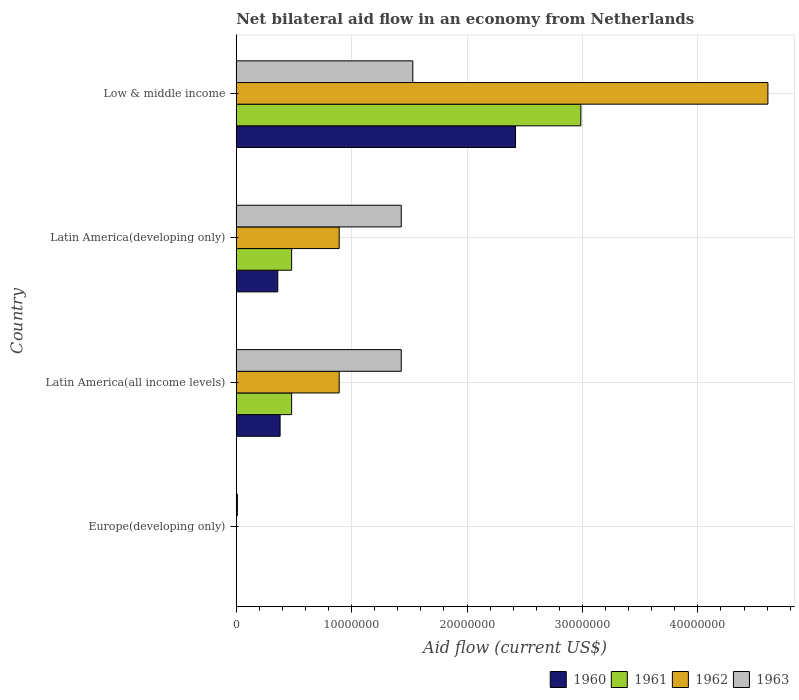How many different coloured bars are there?
Offer a terse response. 4. How many bars are there on the 4th tick from the top?
Ensure brevity in your answer.  1. How many bars are there on the 3rd tick from the bottom?
Offer a terse response. 4. What is the label of the 2nd group of bars from the top?
Provide a short and direct response. Latin America(developing only). What is the net bilateral aid flow in 1962 in Europe(developing only)?
Ensure brevity in your answer.  0. Across all countries, what is the maximum net bilateral aid flow in 1961?
Give a very brief answer. 2.99e+07. Across all countries, what is the minimum net bilateral aid flow in 1960?
Ensure brevity in your answer.  0. What is the total net bilateral aid flow in 1962 in the graph?
Your answer should be compact. 6.39e+07. What is the difference between the net bilateral aid flow in 1963 in Europe(developing only) and that in Latin America(developing only)?
Provide a succinct answer. -1.42e+07. What is the difference between the net bilateral aid flow in 1963 in Latin America(developing only) and the net bilateral aid flow in 1960 in Low & middle income?
Ensure brevity in your answer.  -9.90e+06. What is the average net bilateral aid flow in 1963 per country?
Your response must be concise. 1.10e+07. What is the difference between the net bilateral aid flow in 1962 and net bilateral aid flow in 1963 in Latin America(developing only)?
Your response must be concise. -5.38e+06. What is the ratio of the net bilateral aid flow in 1962 in Latin America(developing only) to that in Low & middle income?
Your response must be concise. 0.19. Is the difference between the net bilateral aid flow in 1962 in Latin America(developing only) and Low & middle income greater than the difference between the net bilateral aid flow in 1963 in Latin America(developing only) and Low & middle income?
Provide a short and direct response. No. What is the difference between the highest and the second highest net bilateral aid flow in 1962?
Your answer should be very brief. 3.72e+07. What is the difference between the highest and the lowest net bilateral aid flow in 1961?
Offer a terse response. 2.99e+07. Is it the case that in every country, the sum of the net bilateral aid flow in 1962 and net bilateral aid flow in 1963 is greater than the net bilateral aid flow in 1960?
Provide a succinct answer. Yes. What is the difference between two consecutive major ticks on the X-axis?
Your answer should be compact. 1.00e+07. Are the values on the major ticks of X-axis written in scientific E-notation?
Offer a very short reply. No. Does the graph contain any zero values?
Make the answer very short. Yes. Does the graph contain grids?
Provide a short and direct response. Yes. How are the legend labels stacked?
Make the answer very short. Horizontal. What is the title of the graph?
Keep it short and to the point. Net bilateral aid flow in an economy from Netherlands. Does "1990" appear as one of the legend labels in the graph?
Provide a short and direct response. No. What is the Aid flow (current US$) in 1960 in Europe(developing only)?
Provide a succinct answer. 0. What is the Aid flow (current US$) in 1962 in Europe(developing only)?
Make the answer very short. 0. What is the Aid flow (current US$) in 1963 in Europe(developing only)?
Offer a very short reply. 1.00e+05. What is the Aid flow (current US$) in 1960 in Latin America(all income levels)?
Offer a terse response. 3.80e+06. What is the Aid flow (current US$) of 1961 in Latin America(all income levels)?
Offer a very short reply. 4.80e+06. What is the Aid flow (current US$) of 1962 in Latin America(all income levels)?
Offer a very short reply. 8.92e+06. What is the Aid flow (current US$) of 1963 in Latin America(all income levels)?
Provide a succinct answer. 1.43e+07. What is the Aid flow (current US$) in 1960 in Latin America(developing only)?
Provide a short and direct response. 3.60e+06. What is the Aid flow (current US$) in 1961 in Latin America(developing only)?
Offer a very short reply. 4.80e+06. What is the Aid flow (current US$) in 1962 in Latin America(developing only)?
Ensure brevity in your answer.  8.92e+06. What is the Aid flow (current US$) of 1963 in Latin America(developing only)?
Your answer should be very brief. 1.43e+07. What is the Aid flow (current US$) of 1960 in Low & middle income?
Provide a short and direct response. 2.42e+07. What is the Aid flow (current US$) of 1961 in Low & middle income?
Your answer should be very brief. 2.99e+07. What is the Aid flow (current US$) of 1962 in Low & middle income?
Keep it short and to the point. 4.61e+07. What is the Aid flow (current US$) of 1963 in Low & middle income?
Provide a succinct answer. 1.53e+07. Across all countries, what is the maximum Aid flow (current US$) of 1960?
Offer a terse response. 2.42e+07. Across all countries, what is the maximum Aid flow (current US$) in 1961?
Ensure brevity in your answer.  2.99e+07. Across all countries, what is the maximum Aid flow (current US$) in 1962?
Provide a short and direct response. 4.61e+07. Across all countries, what is the maximum Aid flow (current US$) of 1963?
Give a very brief answer. 1.53e+07. Across all countries, what is the minimum Aid flow (current US$) in 1960?
Give a very brief answer. 0. What is the total Aid flow (current US$) of 1960 in the graph?
Your answer should be very brief. 3.16e+07. What is the total Aid flow (current US$) of 1961 in the graph?
Provide a short and direct response. 3.95e+07. What is the total Aid flow (current US$) in 1962 in the graph?
Your answer should be very brief. 6.39e+07. What is the total Aid flow (current US$) of 1963 in the graph?
Make the answer very short. 4.40e+07. What is the difference between the Aid flow (current US$) in 1963 in Europe(developing only) and that in Latin America(all income levels)?
Keep it short and to the point. -1.42e+07. What is the difference between the Aid flow (current US$) of 1963 in Europe(developing only) and that in Latin America(developing only)?
Offer a very short reply. -1.42e+07. What is the difference between the Aid flow (current US$) of 1963 in Europe(developing only) and that in Low & middle income?
Ensure brevity in your answer.  -1.52e+07. What is the difference between the Aid flow (current US$) of 1963 in Latin America(all income levels) and that in Latin America(developing only)?
Make the answer very short. 0. What is the difference between the Aid flow (current US$) of 1960 in Latin America(all income levels) and that in Low & middle income?
Offer a very short reply. -2.04e+07. What is the difference between the Aid flow (current US$) in 1961 in Latin America(all income levels) and that in Low & middle income?
Ensure brevity in your answer.  -2.51e+07. What is the difference between the Aid flow (current US$) of 1962 in Latin America(all income levels) and that in Low & middle income?
Ensure brevity in your answer.  -3.72e+07. What is the difference between the Aid flow (current US$) of 1960 in Latin America(developing only) and that in Low & middle income?
Keep it short and to the point. -2.06e+07. What is the difference between the Aid flow (current US$) of 1961 in Latin America(developing only) and that in Low & middle income?
Give a very brief answer. -2.51e+07. What is the difference between the Aid flow (current US$) of 1962 in Latin America(developing only) and that in Low & middle income?
Provide a succinct answer. -3.72e+07. What is the difference between the Aid flow (current US$) of 1960 in Latin America(all income levels) and the Aid flow (current US$) of 1962 in Latin America(developing only)?
Offer a terse response. -5.12e+06. What is the difference between the Aid flow (current US$) of 1960 in Latin America(all income levels) and the Aid flow (current US$) of 1963 in Latin America(developing only)?
Your answer should be compact. -1.05e+07. What is the difference between the Aid flow (current US$) in 1961 in Latin America(all income levels) and the Aid flow (current US$) in 1962 in Latin America(developing only)?
Offer a terse response. -4.12e+06. What is the difference between the Aid flow (current US$) in 1961 in Latin America(all income levels) and the Aid flow (current US$) in 1963 in Latin America(developing only)?
Keep it short and to the point. -9.50e+06. What is the difference between the Aid flow (current US$) in 1962 in Latin America(all income levels) and the Aid flow (current US$) in 1963 in Latin America(developing only)?
Provide a succinct answer. -5.38e+06. What is the difference between the Aid flow (current US$) of 1960 in Latin America(all income levels) and the Aid flow (current US$) of 1961 in Low & middle income?
Your answer should be compact. -2.61e+07. What is the difference between the Aid flow (current US$) of 1960 in Latin America(all income levels) and the Aid flow (current US$) of 1962 in Low & middle income?
Your response must be concise. -4.23e+07. What is the difference between the Aid flow (current US$) in 1960 in Latin America(all income levels) and the Aid flow (current US$) in 1963 in Low & middle income?
Your response must be concise. -1.15e+07. What is the difference between the Aid flow (current US$) of 1961 in Latin America(all income levels) and the Aid flow (current US$) of 1962 in Low & middle income?
Your response must be concise. -4.13e+07. What is the difference between the Aid flow (current US$) in 1961 in Latin America(all income levels) and the Aid flow (current US$) in 1963 in Low & middle income?
Your response must be concise. -1.05e+07. What is the difference between the Aid flow (current US$) in 1962 in Latin America(all income levels) and the Aid flow (current US$) in 1963 in Low & middle income?
Offer a terse response. -6.38e+06. What is the difference between the Aid flow (current US$) of 1960 in Latin America(developing only) and the Aid flow (current US$) of 1961 in Low & middle income?
Offer a very short reply. -2.63e+07. What is the difference between the Aid flow (current US$) in 1960 in Latin America(developing only) and the Aid flow (current US$) in 1962 in Low & middle income?
Provide a short and direct response. -4.25e+07. What is the difference between the Aid flow (current US$) in 1960 in Latin America(developing only) and the Aid flow (current US$) in 1963 in Low & middle income?
Your answer should be compact. -1.17e+07. What is the difference between the Aid flow (current US$) in 1961 in Latin America(developing only) and the Aid flow (current US$) in 1962 in Low & middle income?
Your answer should be compact. -4.13e+07. What is the difference between the Aid flow (current US$) in 1961 in Latin America(developing only) and the Aid flow (current US$) in 1963 in Low & middle income?
Offer a terse response. -1.05e+07. What is the difference between the Aid flow (current US$) in 1962 in Latin America(developing only) and the Aid flow (current US$) in 1963 in Low & middle income?
Offer a very short reply. -6.38e+06. What is the average Aid flow (current US$) in 1960 per country?
Your answer should be compact. 7.90e+06. What is the average Aid flow (current US$) of 1961 per country?
Provide a succinct answer. 9.86e+06. What is the average Aid flow (current US$) in 1962 per country?
Your response must be concise. 1.60e+07. What is the average Aid flow (current US$) of 1963 per country?
Ensure brevity in your answer.  1.10e+07. What is the difference between the Aid flow (current US$) in 1960 and Aid flow (current US$) in 1961 in Latin America(all income levels)?
Ensure brevity in your answer.  -1.00e+06. What is the difference between the Aid flow (current US$) in 1960 and Aid flow (current US$) in 1962 in Latin America(all income levels)?
Make the answer very short. -5.12e+06. What is the difference between the Aid flow (current US$) of 1960 and Aid flow (current US$) of 1963 in Latin America(all income levels)?
Give a very brief answer. -1.05e+07. What is the difference between the Aid flow (current US$) in 1961 and Aid flow (current US$) in 1962 in Latin America(all income levels)?
Your answer should be compact. -4.12e+06. What is the difference between the Aid flow (current US$) of 1961 and Aid flow (current US$) of 1963 in Latin America(all income levels)?
Give a very brief answer. -9.50e+06. What is the difference between the Aid flow (current US$) in 1962 and Aid flow (current US$) in 1963 in Latin America(all income levels)?
Ensure brevity in your answer.  -5.38e+06. What is the difference between the Aid flow (current US$) of 1960 and Aid flow (current US$) of 1961 in Latin America(developing only)?
Ensure brevity in your answer.  -1.20e+06. What is the difference between the Aid flow (current US$) in 1960 and Aid flow (current US$) in 1962 in Latin America(developing only)?
Offer a terse response. -5.32e+06. What is the difference between the Aid flow (current US$) in 1960 and Aid flow (current US$) in 1963 in Latin America(developing only)?
Provide a short and direct response. -1.07e+07. What is the difference between the Aid flow (current US$) of 1961 and Aid flow (current US$) of 1962 in Latin America(developing only)?
Offer a terse response. -4.12e+06. What is the difference between the Aid flow (current US$) of 1961 and Aid flow (current US$) of 1963 in Latin America(developing only)?
Ensure brevity in your answer.  -9.50e+06. What is the difference between the Aid flow (current US$) of 1962 and Aid flow (current US$) of 1963 in Latin America(developing only)?
Your answer should be compact. -5.38e+06. What is the difference between the Aid flow (current US$) of 1960 and Aid flow (current US$) of 1961 in Low & middle income?
Your answer should be compact. -5.66e+06. What is the difference between the Aid flow (current US$) in 1960 and Aid flow (current US$) in 1962 in Low & middle income?
Your answer should be very brief. -2.19e+07. What is the difference between the Aid flow (current US$) of 1960 and Aid flow (current US$) of 1963 in Low & middle income?
Offer a terse response. 8.90e+06. What is the difference between the Aid flow (current US$) in 1961 and Aid flow (current US$) in 1962 in Low & middle income?
Provide a succinct answer. -1.62e+07. What is the difference between the Aid flow (current US$) in 1961 and Aid flow (current US$) in 1963 in Low & middle income?
Provide a succinct answer. 1.46e+07. What is the difference between the Aid flow (current US$) in 1962 and Aid flow (current US$) in 1963 in Low & middle income?
Your response must be concise. 3.08e+07. What is the ratio of the Aid flow (current US$) in 1963 in Europe(developing only) to that in Latin America(all income levels)?
Keep it short and to the point. 0.01. What is the ratio of the Aid flow (current US$) of 1963 in Europe(developing only) to that in Latin America(developing only)?
Your response must be concise. 0.01. What is the ratio of the Aid flow (current US$) of 1963 in Europe(developing only) to that in Low & middle income?
Ensure brevity in your answer.  0.01. What is the ratio of the Aid flow (current US$) in 1960 in Latin America(all income levels) to that in Latin America(developing only)?
Offer a terse response. 1.06. What is the ratio of the Aid flow (current US$) of 1963 in Latin America(all income levels) to that in Latin America(developing only)?
Give a very brief answer. 1. What is the ratio of the Aid flow (current US$) of 1960 in Latin America(all income levels) to that in Low & middle income?
Make the answer very short. 0.16. What is the ratio of the Aid flow (current US$) in 1961 in Latin America(all income levels) to that in Low & middle income?
Make the answer very short. 0.16. What is the ratio of the Aid flow (current US$) of 1962 in Latin America(all income levels) to that in Low & middle income?
Ensure brevity in your answer.  0.19. What is the ratio of the Aid flow (current US$) in 1963 in Latin America(all income levels) to that in Low & middle income?
Your response must be concise. 0.93. What is the ratio of the Aid flow (current US$) of 1960 in Latin America(developing only) to that in Low & middle income?
Make the answer very short. 0.15. What is the ratio of the Aid flow (current US$) of 1961 in Latin America(developing only) to that in Low & middle income?
Your answer should be compact. 0.16. What is the ratio of the Aid flow (current US$) in 1962 in Latin America(developing only) to that in Low & middle income?
Your answer should be compact. 0.19. What is the ratio of the Aid flow (current US$) of 1963 in Latin America(developing only) to that in Low & middle income?
Your answer should be very brief. 0.93. What is the difference between the highest and the second highest Aid flow (current US$) of 1960?
Offer a terse response. 2.04e+07. What is the difference between the highest and the second highest Aid flow (current US$) in 1961?
Keep it short and to the point. 2.51e+07. What is the difference between the highest and the second highest Aid flow (current US$) in 1962?
Your answer should be compact. 3.72e+07. What is the difference between the highest and the lowest Aid flow (current US$) of 1960?
Your answer should be very brief. 2.42e+07. What is the difference between the highest and the lowest Aid flow (current US$) of 1961?
Your answer should be very brief. 2.99e+07. What is the difference between the highest and the lowest Aid flow (current US$) of 1962?
Make the answer very short. 4.61e+07. What is the difference between the highest and the lowest Aid flow (current US$) of 1963?
Give a very brief answer. 1.52e+07. 